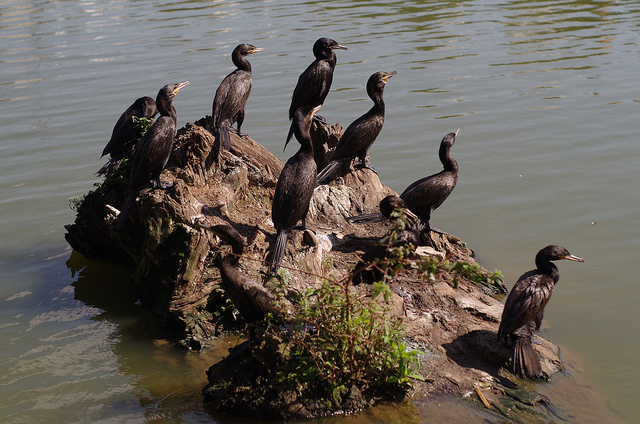<image>What kind of birds are these? I am not certain what kind of birds these are. They could be ducks, seagulls, cranes, geese, or crows. What kind of birds are these? I am not sure what kind of birds are these. It can be ducks, seagull, cranes, geese or crows. 